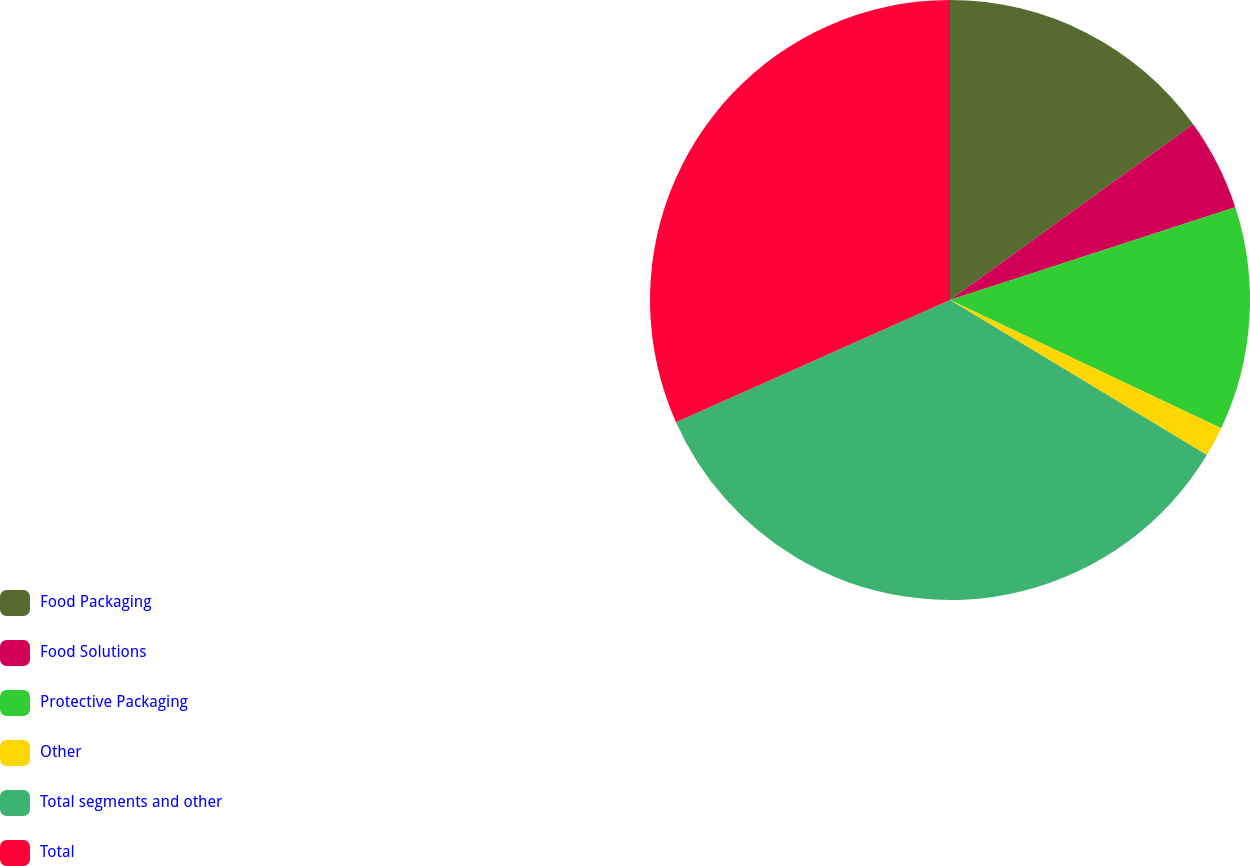Convert chart to OTSL. <chart><loc_0><loc_0><loc_500><loc_500><pie_chart><fcel>Food Packaging<fcel>Food Solutions<fcel>Protective Packaging<fcel>Other<fcel>Total segments and other<fcel>Total<nl><fcel>15.04%<fcel>4.96%<fcel>12.03%<fcel>1.61%<fcel>34.68%<fcel>31.67%<nl></chart> 